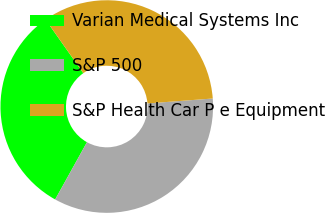Convert chart to OTSL. <chart><loc_0><loc_0><loc_500><loc_500><pie_chart><fcel>Varian Medical Systems Inc<fcel>S&P 500<fcel>S&P Health Car P e Equipment<nl><fcel>32.17%<fcel>34.27%<fcel>33.56%<nl></chart> 